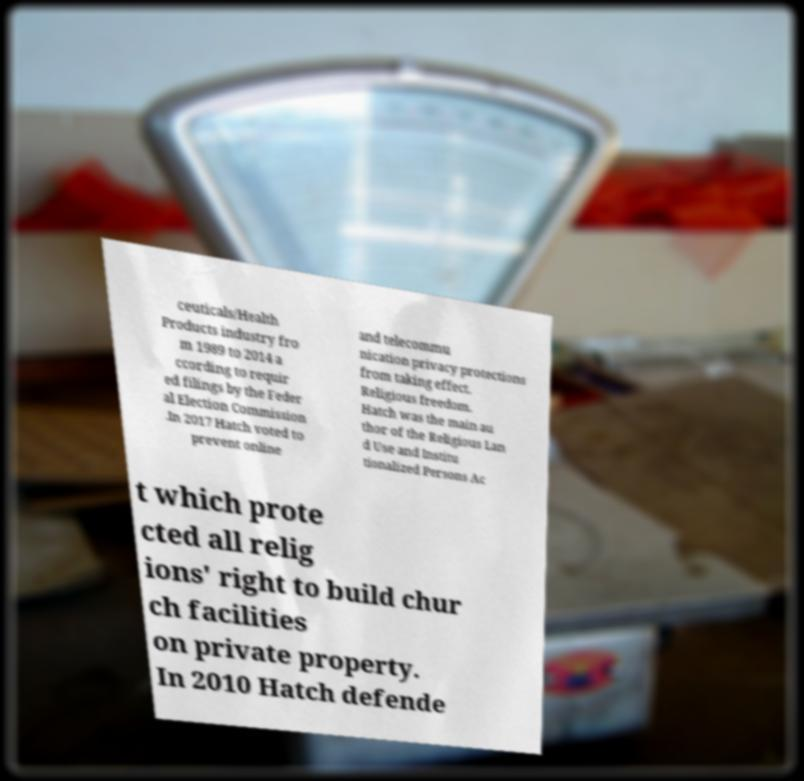What messages or text are displayed in this image? I need them in a readable, typed format. ceuticals/Health Products industry fro m 1989 to 2014 a ccording to requir ed filings by the Feder al Election Commission .In 2017 Hatch voted to prevent online and telecommu nication privacy protections from taking effect. Religious freedom. Hatch was the main au thor of the Religious Lan d Use and Institu tionalized Persons Ac t which prote cted all relig ions' right to build chur ch facilities on private property. In 2010 Hatch defende 